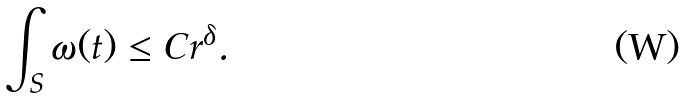<formula> <loc_0><loc_0><loc_500><loc_500>\int _ { S } \omega ( t ) \leq C r ^ { \delta } .</formula> 